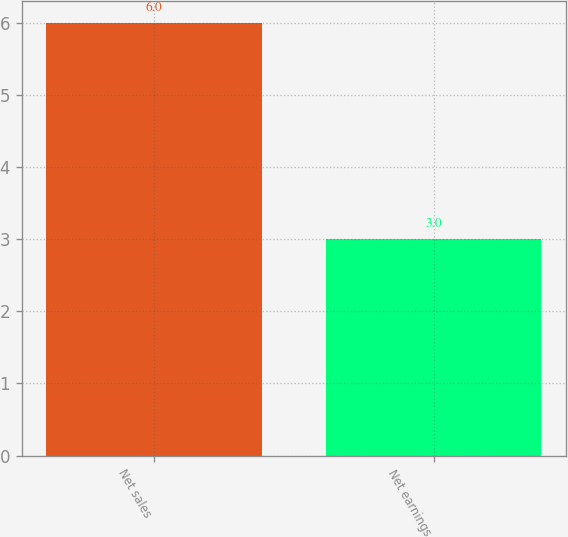<chart> <loc_0><loc_0><loc_500><loc_500><bar_chart><fcel>Net sales<fcel>Net earnings<nl><fcel>6<fcel>3<nl></chart> 